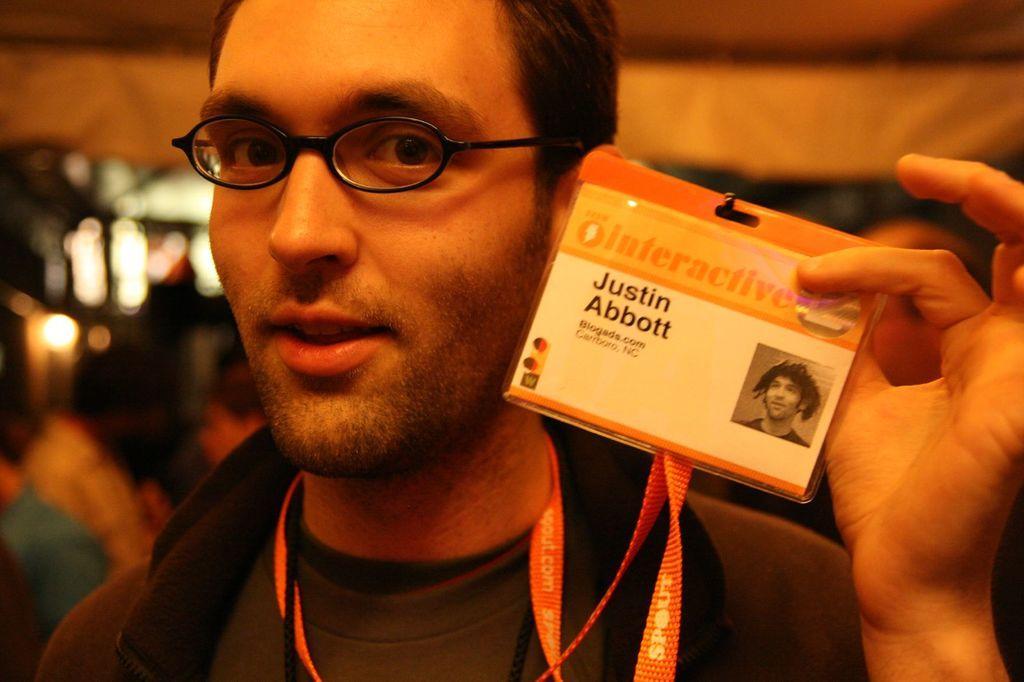Could you give a brief overview of what you see in this image? In this image we can see one man with smiling face wearing an Id card and holding it. There are some objects and some people in the background. The background is blurred. 